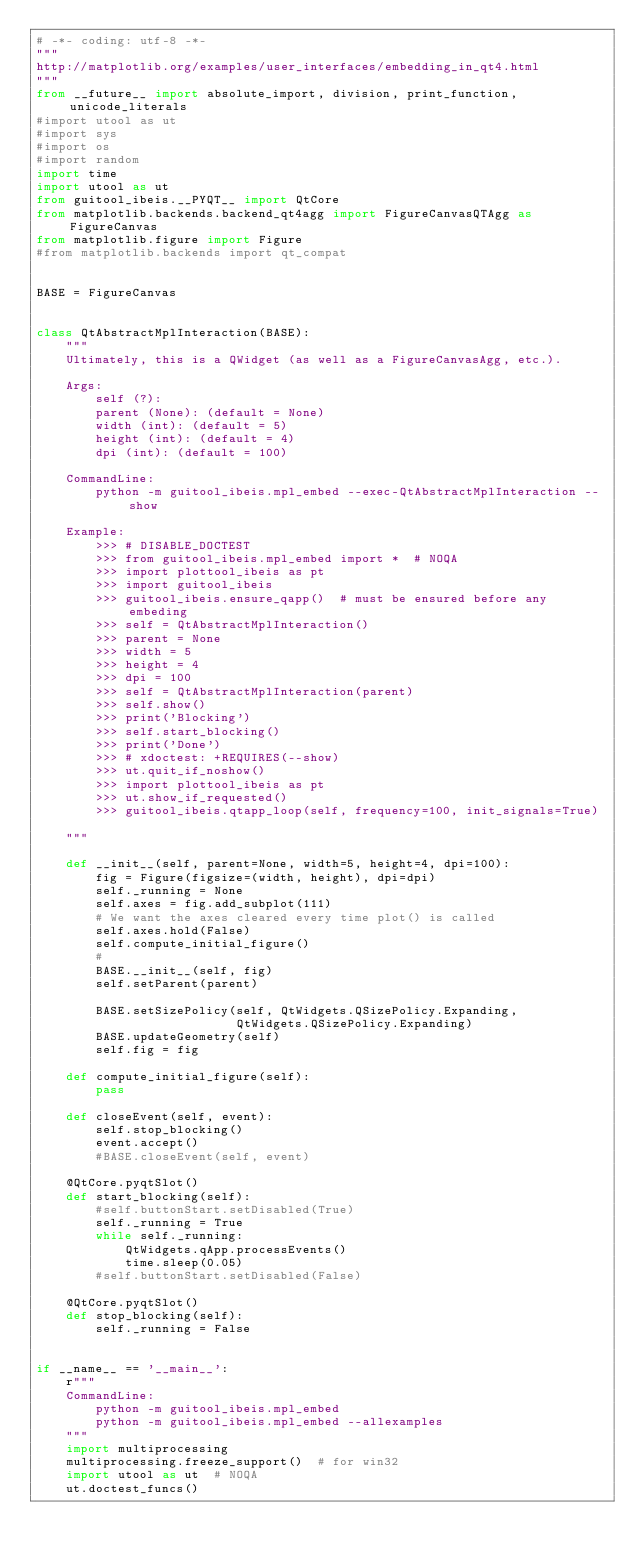<code> <loc_0><loc_0><loc_500><loc_500><_Python_># -*- coding: utf-8 -*-
"""
http://matplotlib.org/examples/user_interfaces/embedding_in_qt4.html
"""
from __future__ import absolute_import, division, print_function, unicode_literals
#import utool as ut
#import sys
#import os
#import random
import time
import utool as ut
from guitool_ibeis.__PYQT__ import QtCore
from matplotlib.backends.backend_qt4agg import FigureCanvasQTAgg as FigureCanvas
from matplotlib.figure import Figure
#from matplotlib.backends import qt_compat


BASE = FigureCanvas


class QtAbstractMplInteraction(BASE):
    """
    Ultimately, this is a QWidget (as well as a FigureCanvasAgg, etc.).

    Args:
        self (?):
        parent (None): (default = None)
        width (int): (default = 5)
        height (int): (default = 4)
        dpi (int): (default = 100)

    CommandLine:
        python -m guitool_ibeis.mpl_embed --exec-QtAbstractMplInteraction --show

    Example:
        >>> # DISABLE_DOCTEST
        >>> from guitool_ibeis.mpl_embed import *  # NOQA
        >>> import plottool_ibeis as pt
        >>> import guitool_ibeis
        >>> guitool_ibeis.ensure_qapp()  # must be ensured before any embeding
        >>> self = QtAbstractMplInteraction()
        >>> parent = None
        >>> width = 5
        >>> height = 4
        >>> dpi = 100
        >>> self = QtAbstractMplInteraction(parent)
        >>> self.show()
        >>> print('Blocking')
        >>> self.start_blocking()
        >>> print('Done')
        >>> # xdoctest: +REQUIRES(--show)
        >>> ut.quit_if_noshow()
        >>> import plottool_ibeis as pt
        >>> ut.show_if_requested()
        >>> guitool_ibeis.qtapp_loop(self, frequency=100, init_signals=True)

    """

    def __init__(self, parent=None, width=5, height=4, dpi=100):
        fig = Figure(figsize=(width, height), dpi=dpi)
        self._running = None
        self.axes = fig.add_subplot(111)
        # We want the axes cleared every time plot() is called
        self.axes.hold(False)
        self.compute_initial_figure()
        #
        BASE.__init__(self, fig)
        self.setParent(parent)

        BASE.setSizePolicy(self, QtWidgets.QSizePolicy.Expanding,
                           QtWidgets.QSizePolicy.Expanding)
        BASE.updateGeometry(self)
        self.fig = fig

    def compute_initial_figure(self):
        pass

    def closeEvent(self, event):
        self.stop_blocking()
        event.accept()
        #BASE.closeEvent(self, event)

    @QtCore.pyqtSlot()
    def start_blocking(self):
        #self.buttonStart.setDisabled(True)
        self._running = True
        while self._running:
            QtWidgets.qApp.processEvents()
            time.sleep(0.05)
        #self.buttonStart.setDisabled(False)

    @QtCore.pyqtSlot()
    def stop_blocking(self):
        self._running = False


if __name__ == '__main__':
    r"""
    CommandLine:
        python -m guitool_ibeis.mpl_embed
        python -m guitool_ibeis.mpl_embed --allexamples
    """
    import multiprocessing
    multiprocessing.freeze_support()  # for win32
    import utool as ut  # NOQA
    ut.doctest_funcs()
</code> 